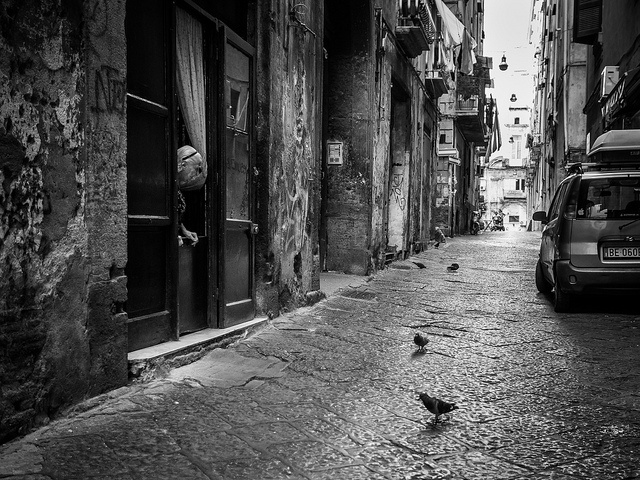Describe the objects in this image and their specific colors. I can see car in black, gray, darkgray, and lightgray tones, people in black, gray, darkgray, and lightgray tones, bird in black, gray, darkgray, and lightgray tones, bird in black, gray, darkgray, and lightgray tones, and bird in black, gray, darkgray, and lightgray tones in this image. 